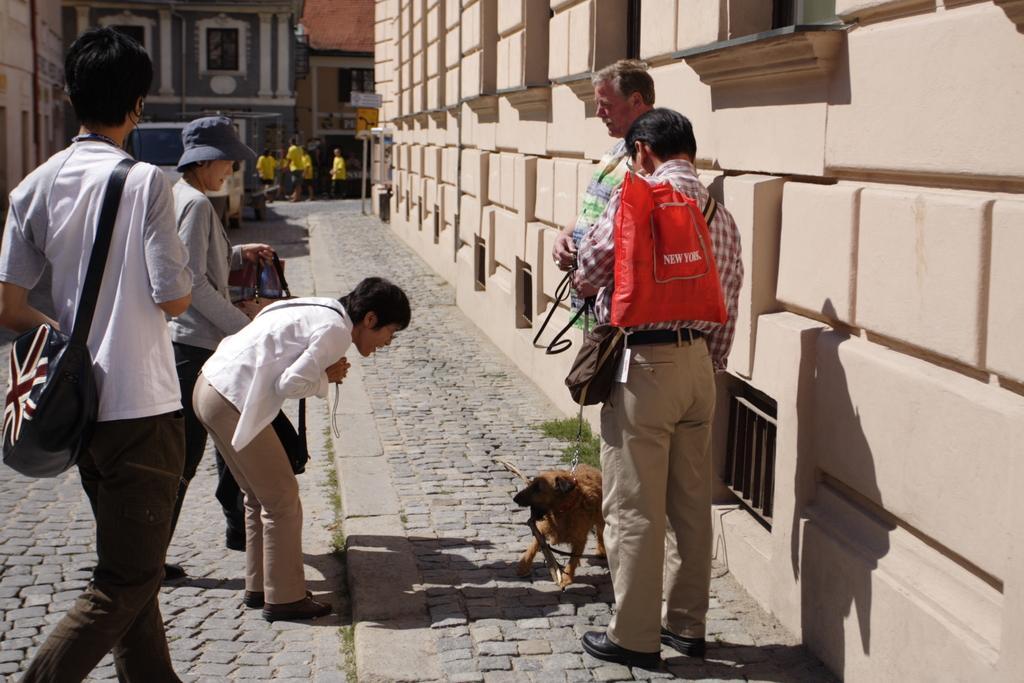In one or two sentences, can you explain what this image depicts? In the picture there are two men standing on footpath, a man is holding a dog with the chain he is also wearing a red color bag,to the left side there are three people the middle person is pampering the dog far away there are few other people they are wearing yellow uniform there is a truck beside them, in the background there are also few other buildings. 